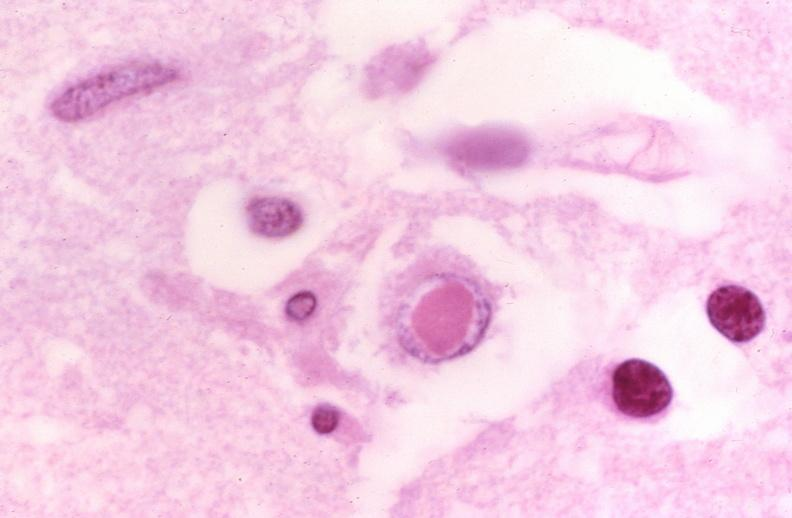what is present?
Answer the question using a single word or phrase. Nervous 